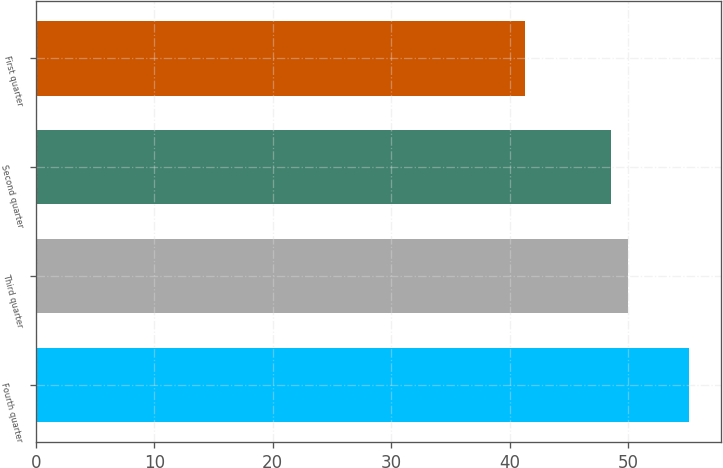Convert chart to OTSL. <chart><loc_0><loc_0><loc_500><loc_500><bar_chart><fcel>Fourth quarter<fcel>Third quarter<fcel>Second quarter<fcel>First quarter<nl><fcel>55.11<fcel>49.94<fcel>48.55<fcel>41.25<nl></chart> 